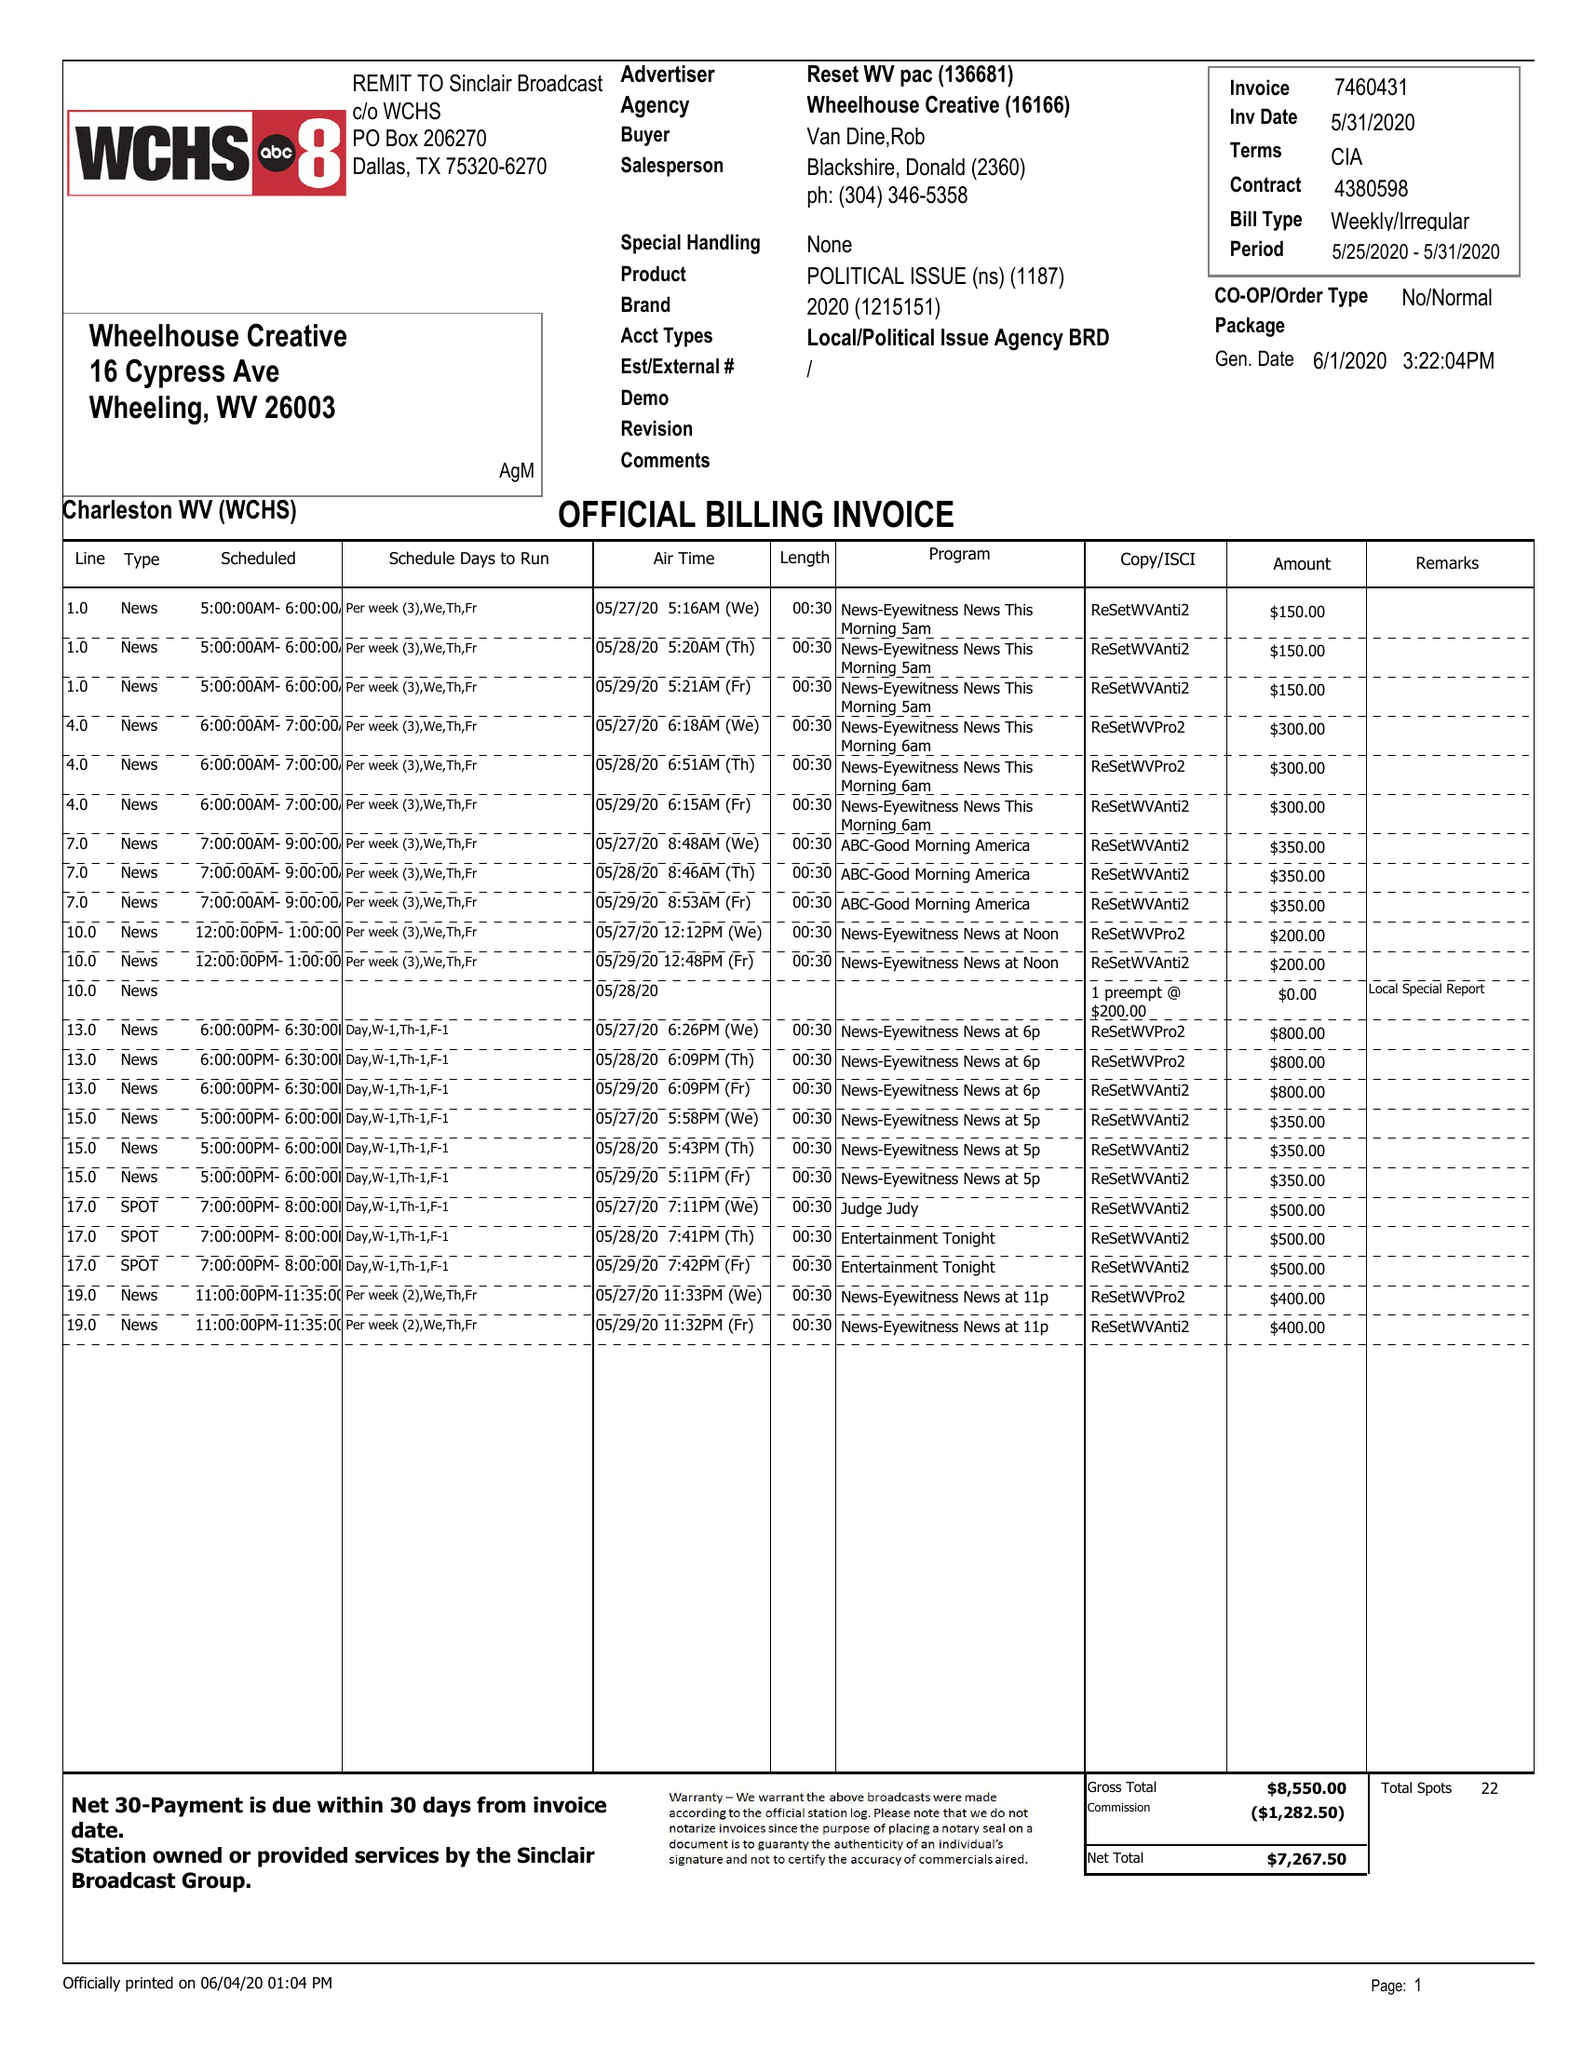What is the value for the contract_num?
Answer the question using a single word or phrase. 4380598 